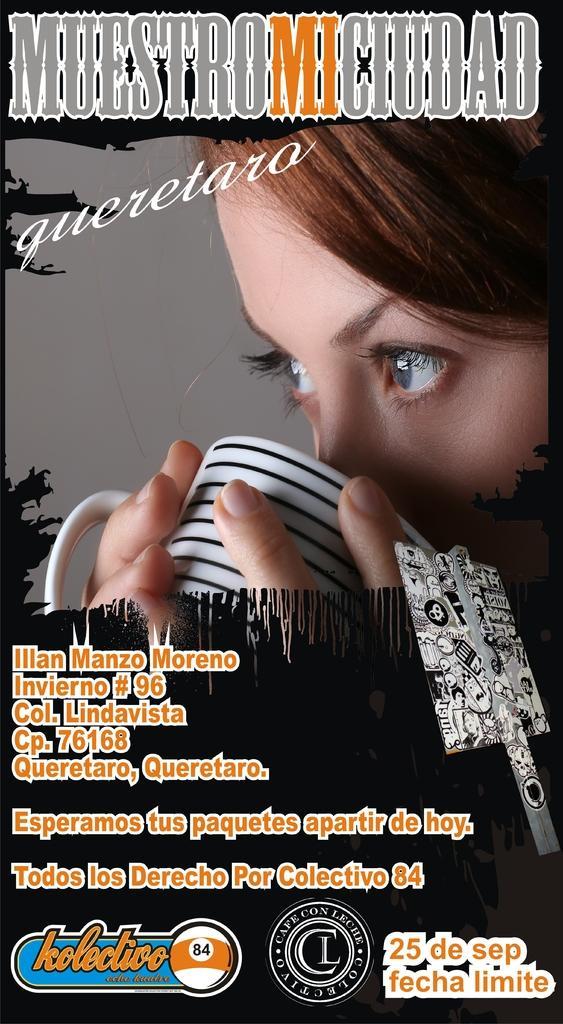What can be found in the image that contains written information? There is text in the image. Who or what is present in the image along with the text? There is a person in the image. What is the person holding in the image? The person is holding a cup. What type of station is depicted in the image? There is no station present in the image. Which organization is responsible for the text in the image? The image does not provide information about the organization responsible for the text. 